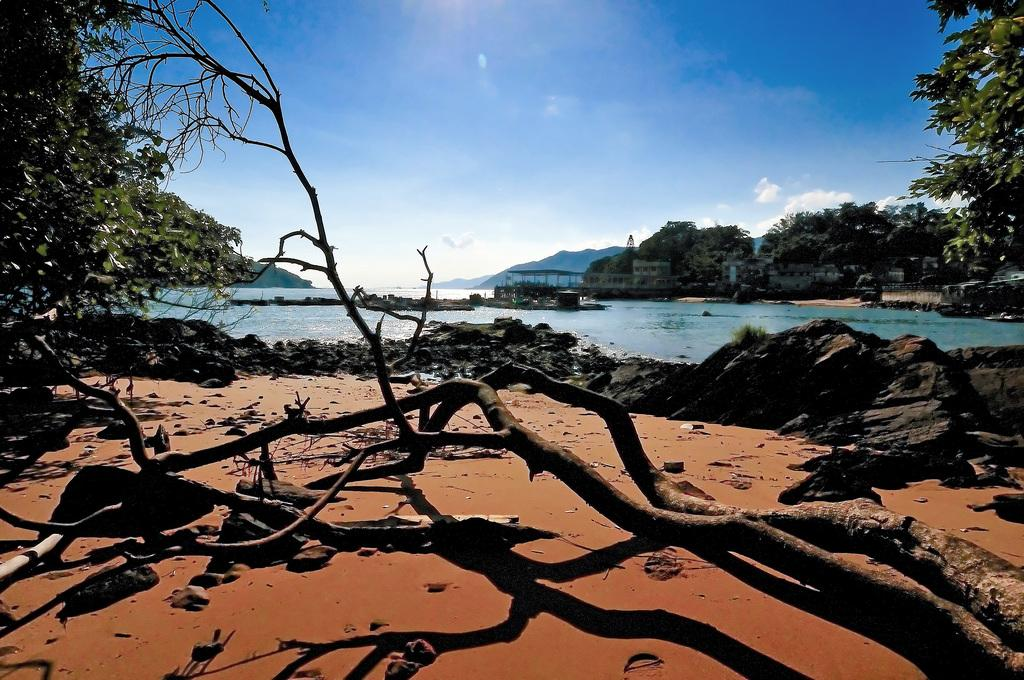What natural elements can be seen in the image? There are branches, rocks, and a river in the image. What structures are visible behind the river? There are buildings and trees behind the river in the image. What geographical features are present behind the river? There are hills behind the river in the image. What part of the natural environment is visible in the image? The sky is visible in the image. What type of wax is being advertised by the secretary in the image? There is no secretary or wax being advertised in the image; it features natural elements and structures. 